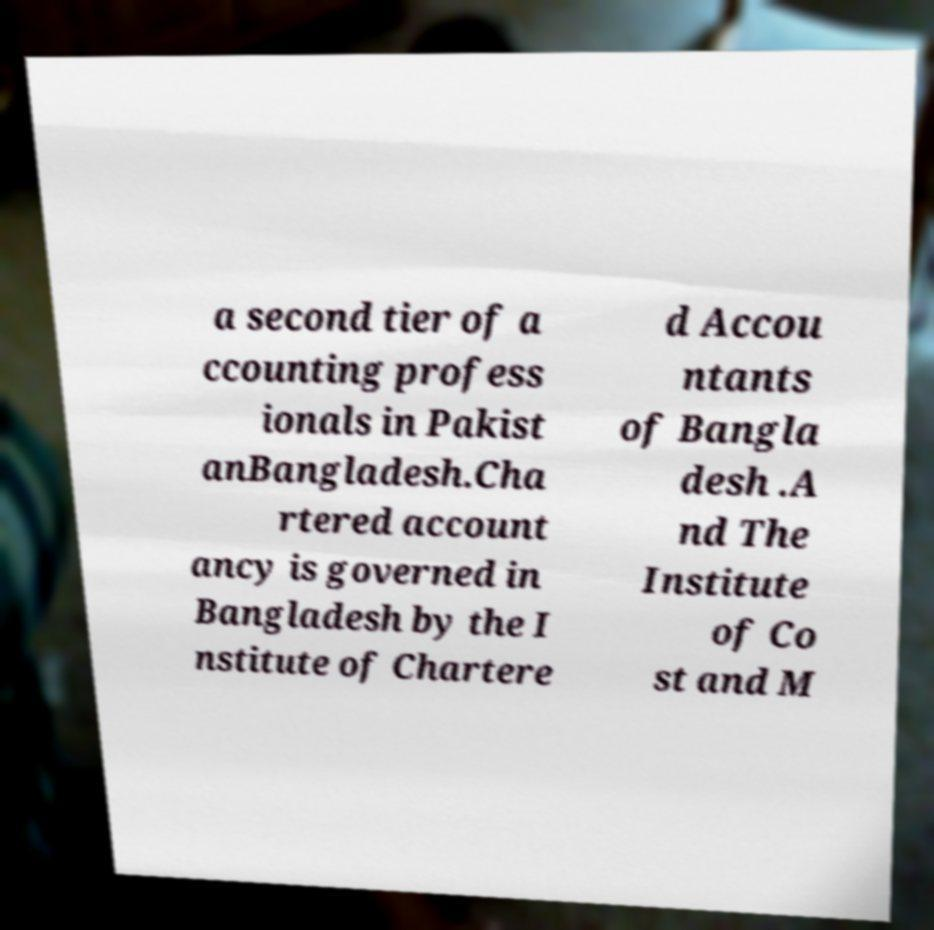For documentation purposes, I need the text within this image transcribed. Could you provide that? a second tier of a ccounting profess ionals in Pakist anBangladesh.Cha rtered account ancy is governed in Bangladesh by the I nstitute of Chartere d Accou ntants of Bangla desh .A nd The Institute of Co st and M 